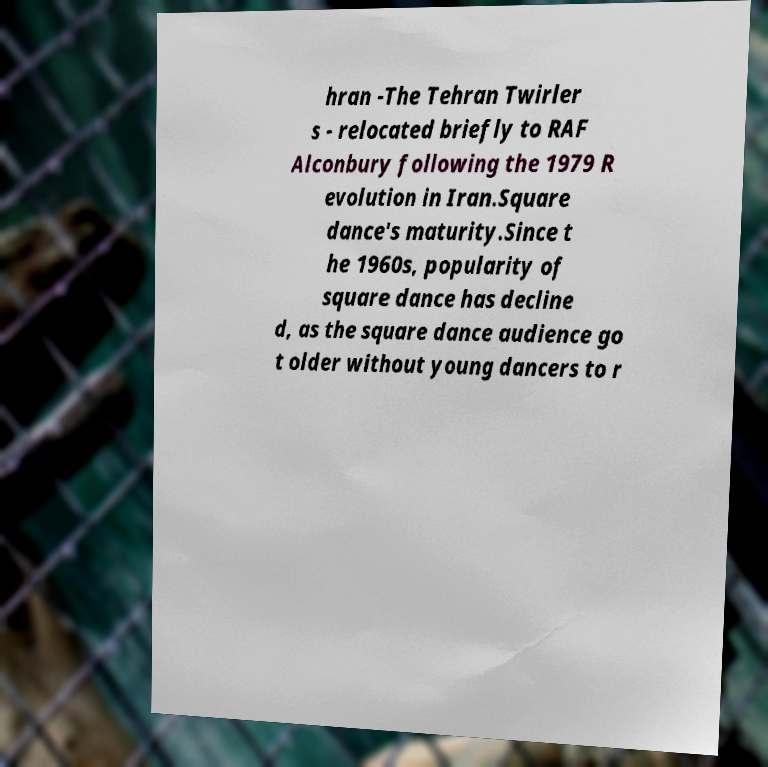What messages or text are displayed in this image? I need them in a readable, typed format. hran -The Tehran Twirler s - relocated briefly to RAF Alconbury following the 1979 R evolution in Iran.Square dance's maturity.Since t he 1960s, popularity of square dance has decline d, as the square dance audience go t older without young dancers to r 